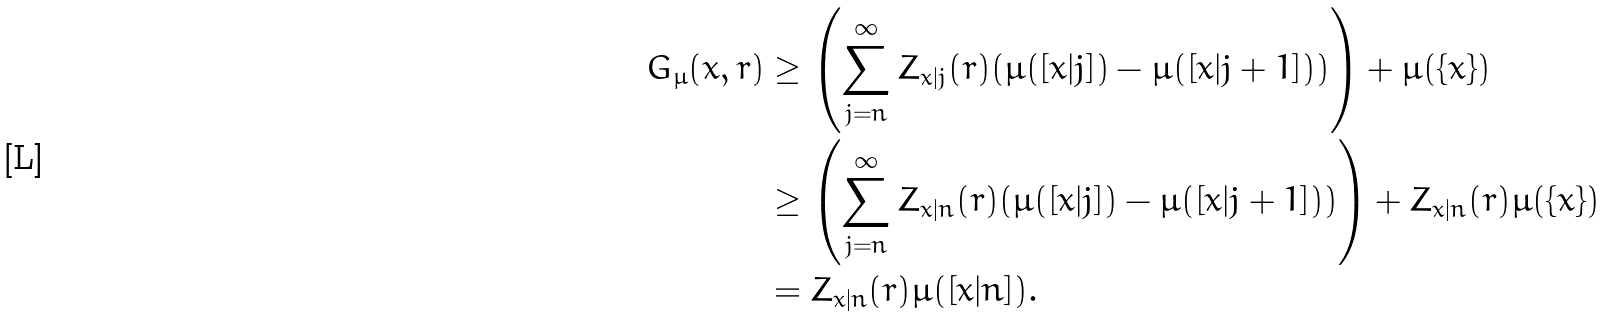Convert formula to latex. <formula><loc_0><loc_0><loc_500><loc_500>G _ { \mu } ( x , r ) & \geq \left ( \sum _ { j = n } ^ { \infty } Z _ { x | j } ( r ) ( \mu ( [ x | j ] ) - \mu ( [ x | j + 1 ] ) ) \right ) + \mu ( \{ x \} ) \\ & \geq \left ( \sum _ { j = n } ^ { \infty } Z _ { x | n } ( r ) ( \mu ( [ x | j ] ) - \mu ( [ x | j + 1 ] ) ) \right ) + Z _ { x | n } ( r ) \mu ( \{ x \} ) \\ & = Z _ { x | n } ( r ) \mu ( [ x | n ] ) .</formula> 